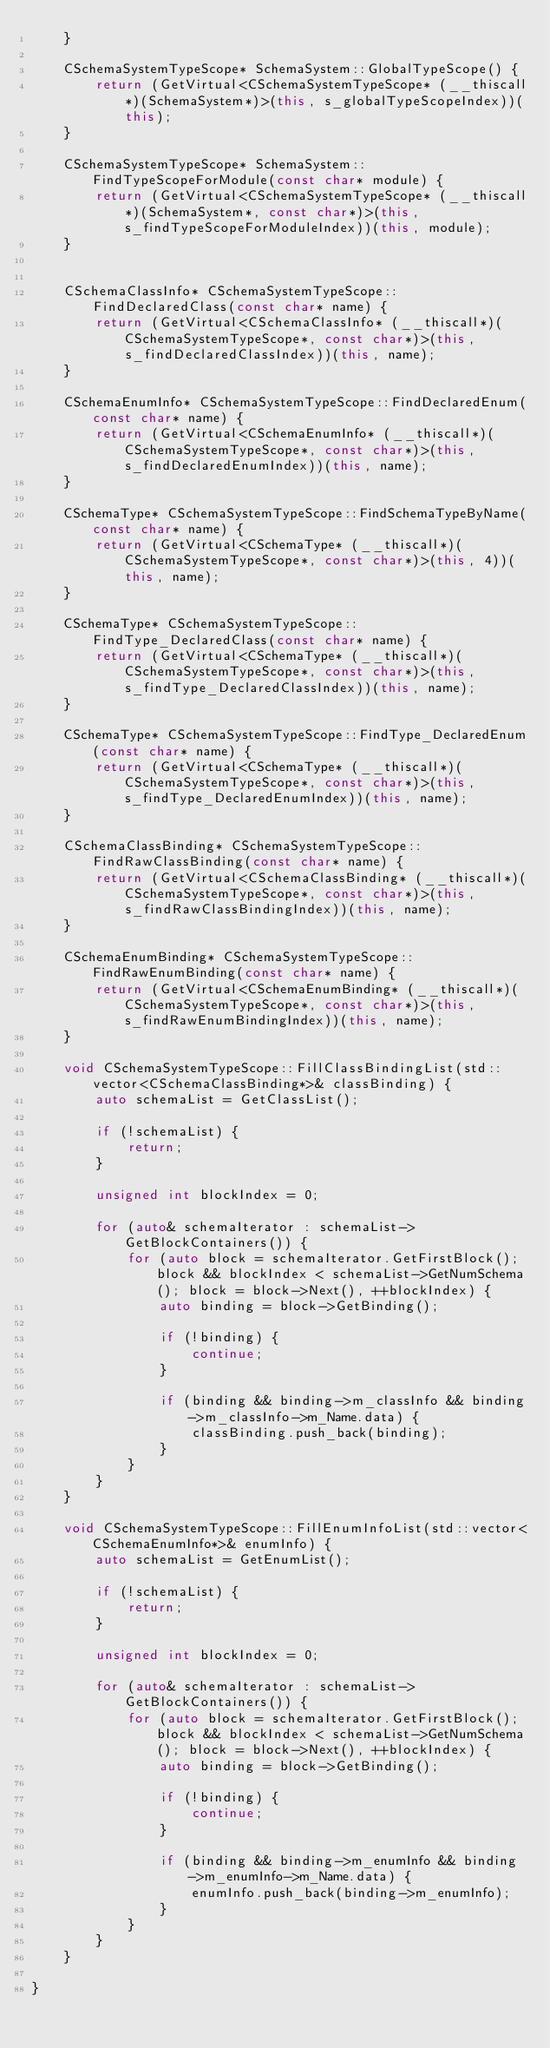<code> <loc_0><loc_0><loc_500><loc_500><_C++_>    }

    CSchemaSystemTypeScope* SchemaSystem::GlobalTypeScope() {
        return (GetVirtual<CSchemaSystemTypeScope* (__thiscall*)(SchemaSystem*)>(this, s_globalTypeScopeIndex))(this);
    }

    CSchemaSystemTypeScope* SchemaSystem::FindTypeScopeForModule(const char* module) {
        return (GetVirtual<CSchemaSystemTypeScope* (__thiscall*)(SchemaSystem*, const char*)>(this, s_findTypeScopeForModuleIndex))(this, module);
    }


    CSchemaClassInfo* CSchemaSystemTypeScope::FindDeclaredClass(const char* name) {
        return (GetVirtual<CSchemaClassInfo* (__thiscall*)(CSchemaSystemTypeScope*, const char*)>(this, s_findDeclaredClassIndex))(this, name);
    }

    CSchemaEnumInfo* CSchemaSystemTypeScope::FindDeclaredEnum(const char* name) {
        return (GetVirtual<CSchemaEnumInfo* (__thiscall*)(CSchemaSystemTypeScope*, const char*)>(this, s_findDeclaredEnumIndex))(this, name);
    }

    CSchemaType* CSchemaSystemTypeScope::FindSchemaTypeByName(const char* name) {
        return (GetVirtual<CSchemaType* (__thiscall*)(CSchemaSystemTypeScope*, const char*)>(this, 4))(this, name);
    }

    CSchemaType* CSchemaSystemTypeScope::FindType_DeclaredClass(const char* name) {
        return (GetVirtual<CSchemaType* (__thiscall*)(CSchemaSystemTypeScope*, const char*)>(this, s_findType_DeclaredClassIndex))(this, name);
    }

    CSchemaType* CSchemaSystemTypeScope::FindType_DeclaredEnum(const char* name) {
        return (GetVirtual<CSchemaType* (__thiscall*)(CSchemaSystemTypeScope*, const char*)>(this, s_findType_DeclaredEnumIndex))(this, name);
    }

    CSchemaClassBinding* CSchemaSystemTypeScope::FindRawClassBinding(const char* name) {
        return (GetVirtual<CSchemaClassBinding* (__thiscall*)(CSchemaSystemTypeScope*, const char*)>(this, s_findRawClassBindingIndex))(this, name);
    }

    CSchemaEnumBinding* CSchemaSystemTypeScope::FindRawEnumBinding(const char* name) {
        return (GetVirtual<CSchemaEnumBinding* (__thiscall*)(CSchemaSystemTypeScope*, const char*)>(this, s_findRawEnumBindingIndex))(this, name);
    }

    void CSchemaSystemTypeScope::FillClassBindingList(std::vector<CSchemaClassBinding*>& classBinding) {
        auto schemaList = GetClassList();

        if (!schemaList) {
            return;
        }

        unsigned int blockIndex = 0;

        for (auto& schemaIterator : schemaList->GetBlockContainers()) {
            for (auto block = schemaIterator.GetFirstBlock(); block && blockIndex < schemaList->GetNumSchema(); block = block->Next(), ++blockIndex) {
                auto binding = block->GetBinding();

                if (!binding) {
                    continue;
                }

                if (binding && binding->m_classInfo && binding->m_classInfo->m_Name.data) {
                    classBinding.push_back(binding);
                }
            }
        }
    }

    void CSchemaSystemTypeScope::FillEnumInfoList(std::vector<CSchemaEnumInfo*>& enumInfo) {
        auto schemaList = GetEnumList();

        if (!schemaList) {
            return;
        }

        unsigned int blockIndex = 0;

        for (auto& schemaIterator : schemaList->GetBlockContainers()) {
            for (auto block = schemaIterator.GetFirstBlock(); block && blockIndex < schemaList->GetNumSchema(); block = block->Next(), ++blockIndex) {
                auto binding = block->GetBinding();

                if (!binding) {
                    continue;
                }

                if (binding && binding->m_enumInfo && binding->m_enumInfo->m_Name.data) {
                    enumInfo.push_back(binding->m_enumInfo);
                }
            }
        }
    }

}</code> 